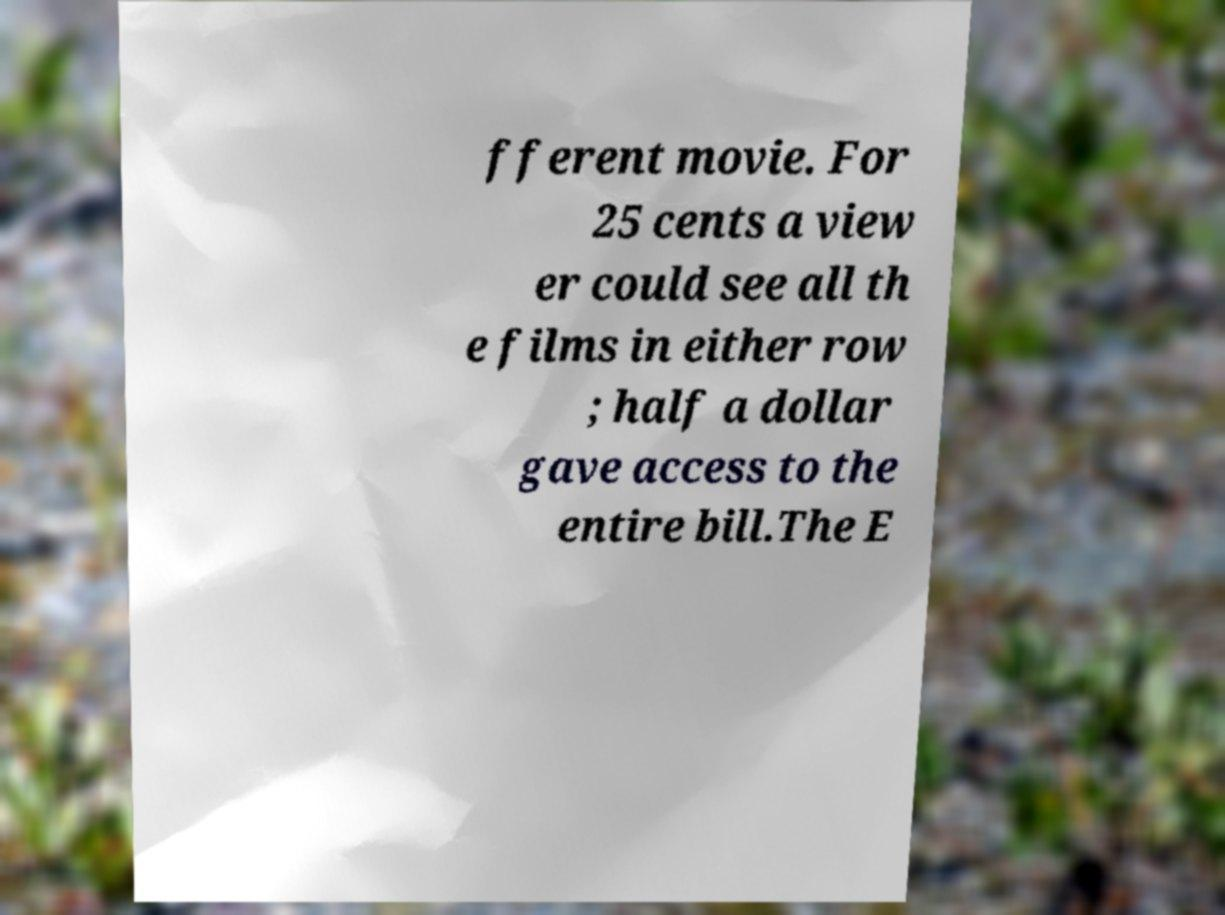Can you accurately transcribe the text from the provided image for me? fferent movie. For 25 cents a view er could see all th e films in either row ; half a dollar gave access to the entire bill.The E 